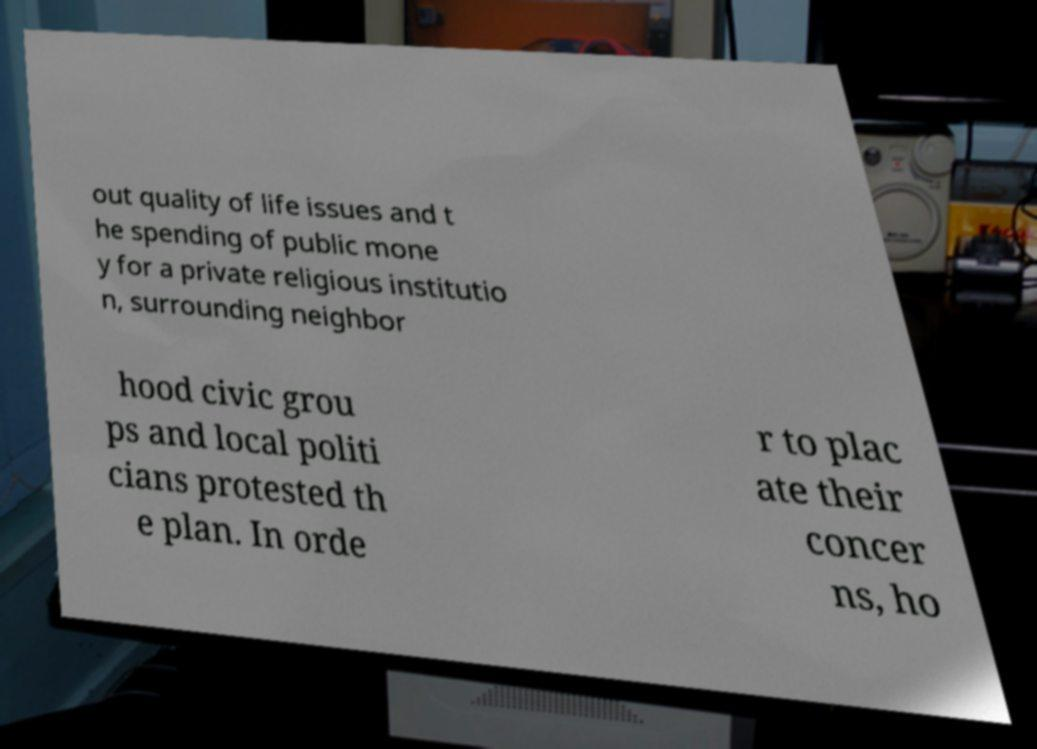What messages or text are displayed in this image? I need them in a readable, typed format. out quality of life issues and t he spending of public mone y for a private religious institutio n, surrounding neighbor hood civic grou ps and local politi cians protested th e plan. In orde r to plac ate their concer ns, ho 